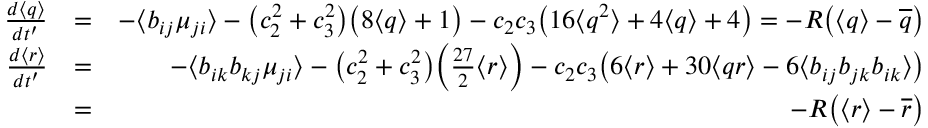Convert formula to latex. <formula><loc_0><loc_0><loc_500><loc_500>\begin{array} { r l r } { \frac { d \langle q \rangle } { d t ^ { \prime } } } & { = } & { - \langle b _ { i j } \mu _ { j i } \rangle - \left ( c _ { 2 } ^ { 2 } + c _ { 3 } ^ { 2 } \right ) \left ( 8 \langle q \rangle + 1 \right ) - c _ { 2 } c _ { 3 } \left ( 1 6 \langle q ^ { 2 } \rangle + 4 \langle q \rangle + 4 \right ) = - R \left ( \langle q \rangle - \overline { q } \right ) } \\ { \frac { d \langle r \rangle } { d t ^ { \prime } } } & { = } & { - \langle b _ { i k } b _ { k j } \mu _ { j i } \rangle - \left ( c _ { 2 } ^ { 2 } + c _ { 3 } ^ { 2 } \right ) \left ( \frac { 2 7 } { 2 } \langle r \rangle \right ) - c _ { 2 } c _ { 3 } \left ( 6 \langle r \rangle + 3 0 \langle q r \rangle - 6 \langle b _ { i j } b _ { j k } b _ { i k } \rangle \right ) } \\ & { = } & { - R \left ( \langle r \rangle - \overline { r } \right ) } \end{array}</formula> 